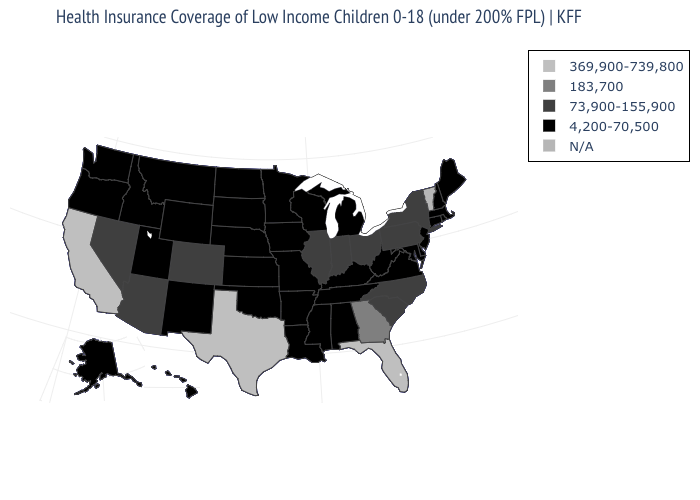Which states hav the highest value in the Northeast?
Short answer required. New York, Pennsylvania. Which states have the lowest value in the USA?
Write a very short answer. Alabama, Alaska, Arkansas, Connecticut, Delaware, Hawaii, Idaho, Iowa, Kansas, Kentucky, Louisiana, Maine, Maryland, Massachusetts, Michigan, Minnesota, Mississippi, Missouri, Montana, Nebraska, New Hampshire, New Jersey, New Mexico, North Dakota, Oklahoma, Oregon, Rhode Island, South Dakota, Tennessee, Utah, Virginia, Washington, West Virginia, Wisconsin, Wyoming. Name the states that have a value in the range N/A?
Give a very brief answer. Vermont. Among the states that border Wisconsin , which have the lowest value?
Concise answer only. Iowa, Michigan, Minnesota. Name the states that have a value in the range 183,700?
Write a very short answer. Georgia. Name the states that have a value in the range N/A?
Quick response, please. Vermont. How many symbols are there in the legend?
Be succinct. 5. What is the lowest value in the USA?
Concise answer only. 4,200-70,500. What is the value of New Jersey?
Keep it brief. 4,200-70,500. Does Florida have the highest value in the USA?
Concise answer only. Yes. Does Idaho have the highest value in the West?
Keep it brief. No. What is the value of Wisconsin?
Concise answer only. 4,200-70,500. What is the highest value in states that border Nevada?
Keep it brief. 369,900-739,800. How many symbols are there in the legend?
Be succinct. 5. 